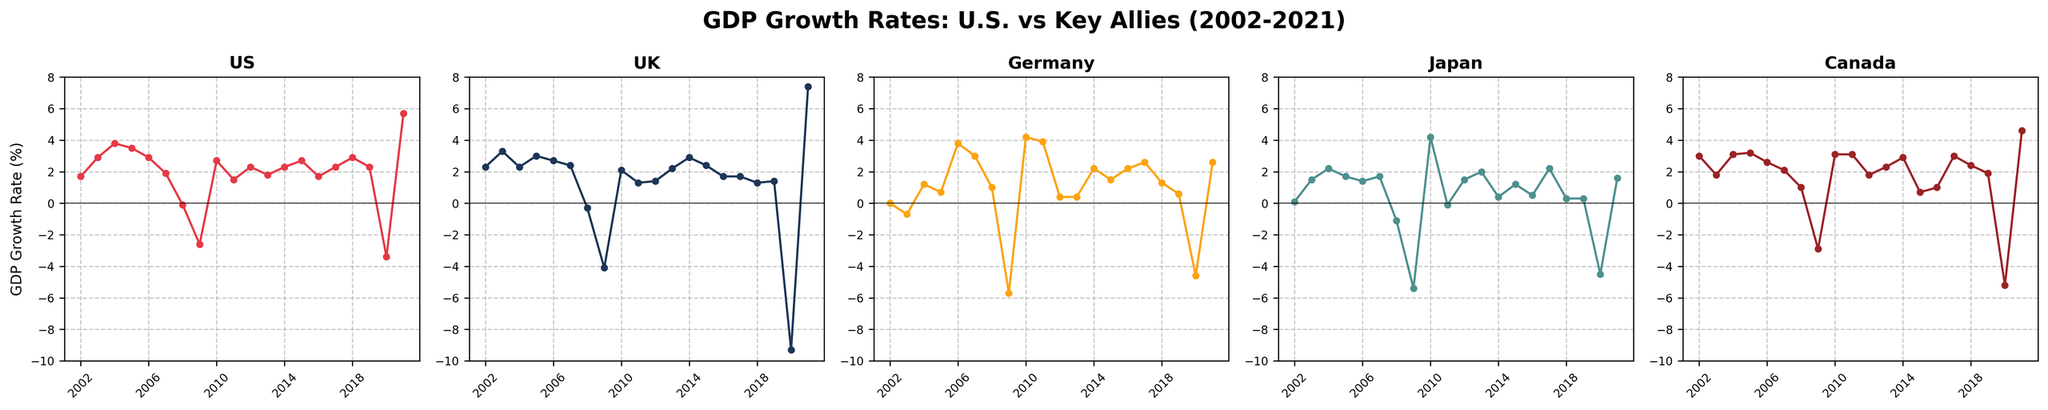Which year had the highest GDP growth rate in the U.S.? Looking at the U.S. subplot, the highest point is visible in 2021.
Answer: 2021 Which country experienced the largest negative GDP growth in 2020? Comparing the points in 2020 across all subplots, the UK shows the lowest point at -9.3%.
Answer: UK In which year did Germany experience its highest GDP growth rate, and what was the value? The peak for Germany is observed in 2010, with a value of 4.2%.
Answer: 2010, 4.2% Compare the GDP growth rates of the U.S. and Japan in 2009. Which country had a smaller decline? Both countries experienced a decline in 2009, but the U.S. declined by -2.6% while Japan declined by -5.4%. The U.S. had a smaller decline.
Answer: U.S Between 2008 and 2010, which country showed the most consistent recovery in GDP growth rates? Analyzing the trend lines in this period, Canada showed a consistent increase from 1.0% in 2008 to 3.1% in 2010.
Answer: Canada Which country had a GDP growth rate closest to 2% in 2013? The subplot for UK has a growth rate of 2.2% in 2013, which is closest to 2%.
Answer: UK How many years did Japan have a GDP growth rate below zero between 2002 to 2021? Counting the points below the zero line in the Japan subplot, there are four years: 2008, 2009, 2011, and 2020.
Answer: 4 What were the GDP growth rates for the U.S., UK, and Germany in 2005, and which country had the second highest growth rate? Checking the specific points for 2005, U.S. (3.5%), UK (3.0%), and Germany (0.7%), the UK had the second highest growth rate.
Answer: UK Which country had the most volatile GDP growth rates over the 20-year period? Observing the range and fluctuation of the growth rates visually, the UK subplot shows significant peaks and dips, indicating high volatility.
Answer: UK 